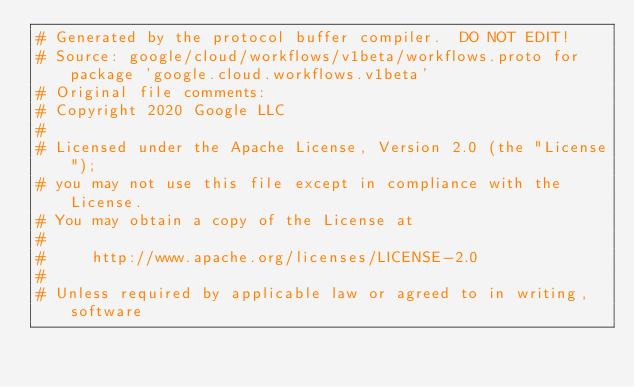Convert code to text. <code><loc_0><loc_0><loc_500><loc_500><_Ruby_># Generated by the protocol buffer compiler.  DO NOT EDIT!
# Source: google/cloud/workflows/v1beta/workflows.proto for package 'google.cloud.workflows.v1beta'
# Original file comments:
# Copyright 2020 Google LLC
#
# Licensed under the Apache License, Version 2.0 (the "License");
# you may not use this file except in compliance with the License.
# You may obtain a copy of the License at
#
#     http://www.apache.org/licenses/LICENSE-2.0
#
# Unless required by applicable law or agreed to in writing, software</code> 